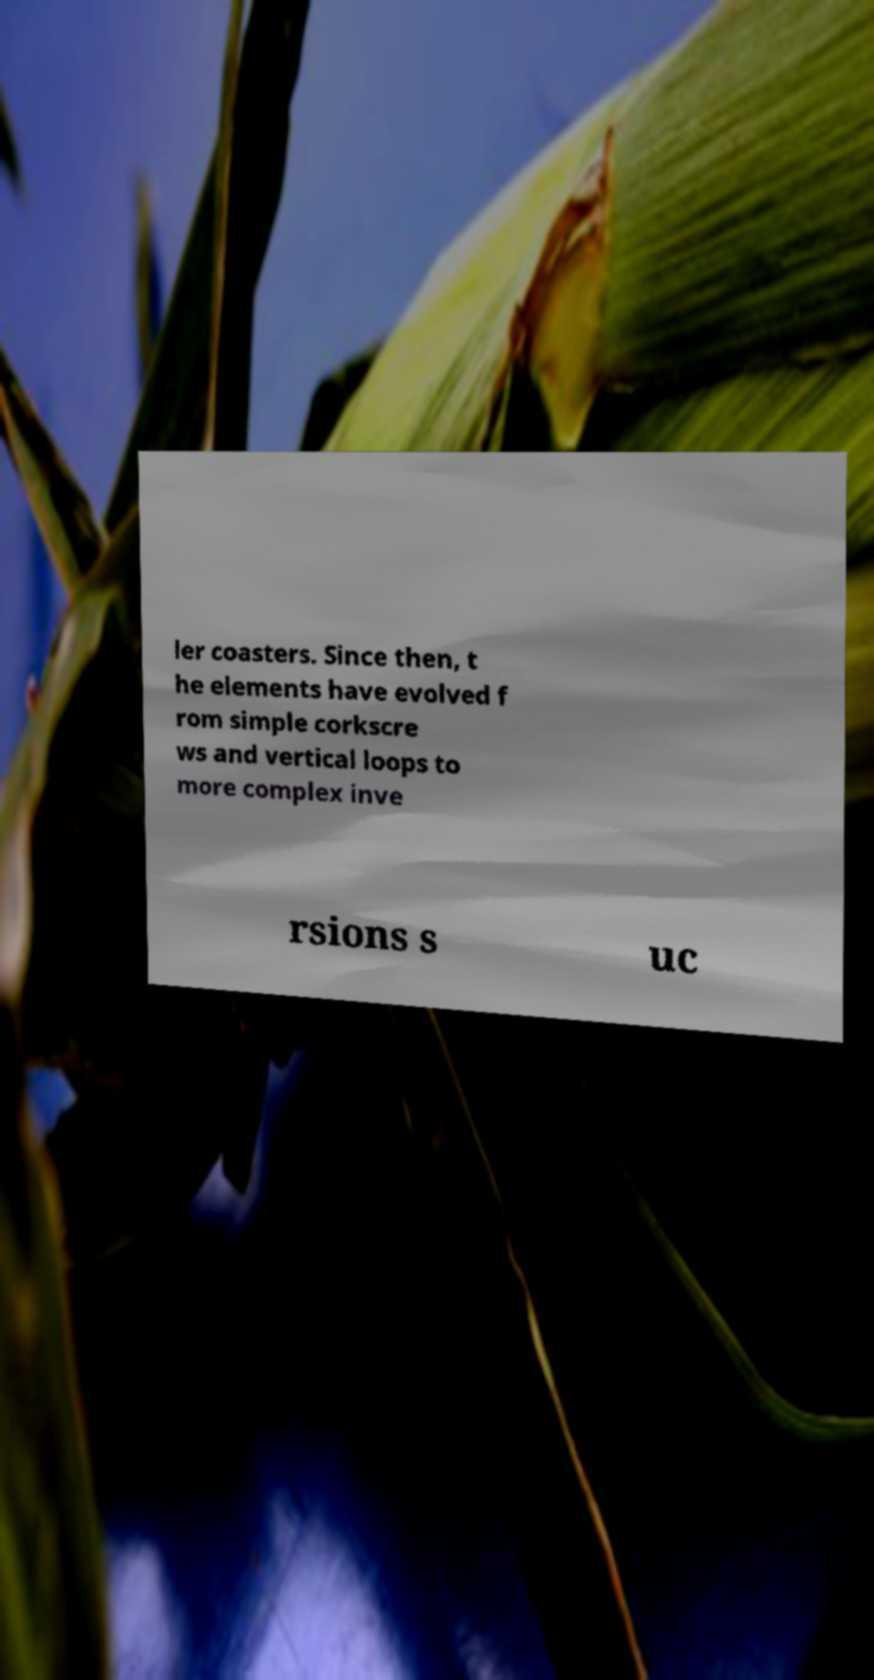Please read and relay the text visible in this image. What does it say? ler coasters. Since then, t he elements have evolved f rom simple corkscre ws and vertical loops to more complex inve rsions s uc 